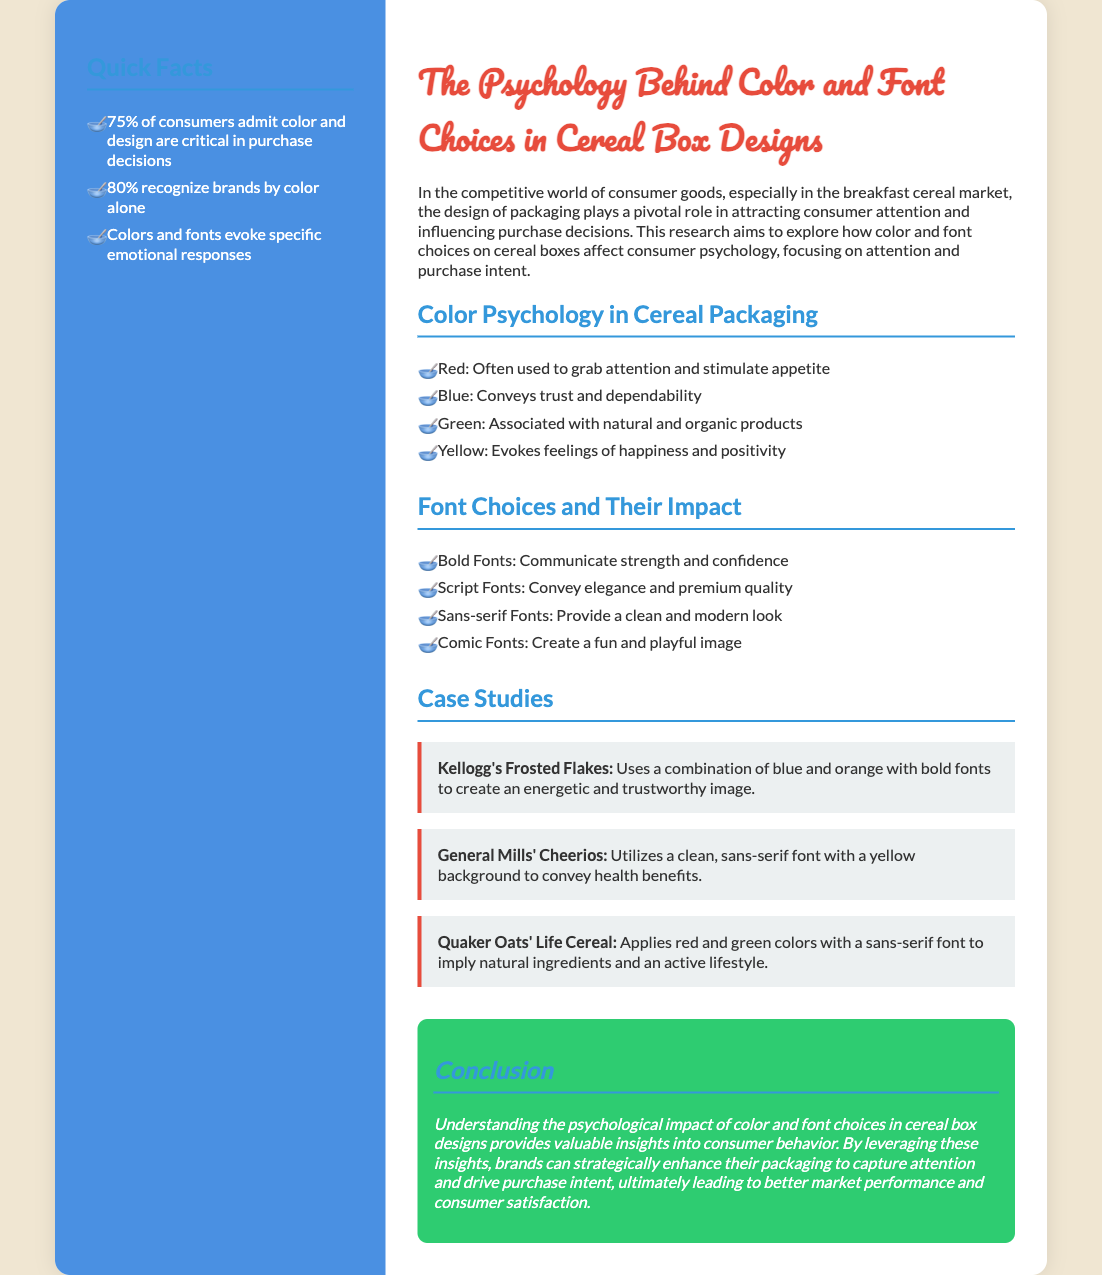what percentage of consumers admit color and design are critical in purchase decisions? The document states that 75% of consumers admit color and design are critical in purchase decisions.
Answer: 75% what color conveys trust and dependability? According to the document, blue conveys trust and dependability.
Answer: blue what font type is used to communicate strength and confidence? The document mentions that bold fonts communicate strength and confidence.
Answer: bold fonts which cereal brand uses a combination of blue and orange? The case study specifies that Kellogg's Frosted Flakes uses a combination of blue and orange.
Answer: Kellogg's Frosted Flakes which color is associated with natural and organic products? The document indicates that green is associated with natural and organic products.
Answer: green what emotion does yellow evoke? Yellow is stated in the document to evoke feelings of happiness and positivity.
Answer: happiness and positivity how do script fonts convey their message? The document explains that script fonts convey elegance and premium quality.
Answer: elegance and premium quality what is the main focus of the research? The main focus of the research is on how color and font choices affect consumer psychology, focusing on attention and purchase intent.
Answer: consumer psychology what color combination does Quaker Oats' Life Cereal apply? The document specifies that Quaker Oats' Life Cereal applies red and green colors.
Answer: red and green 